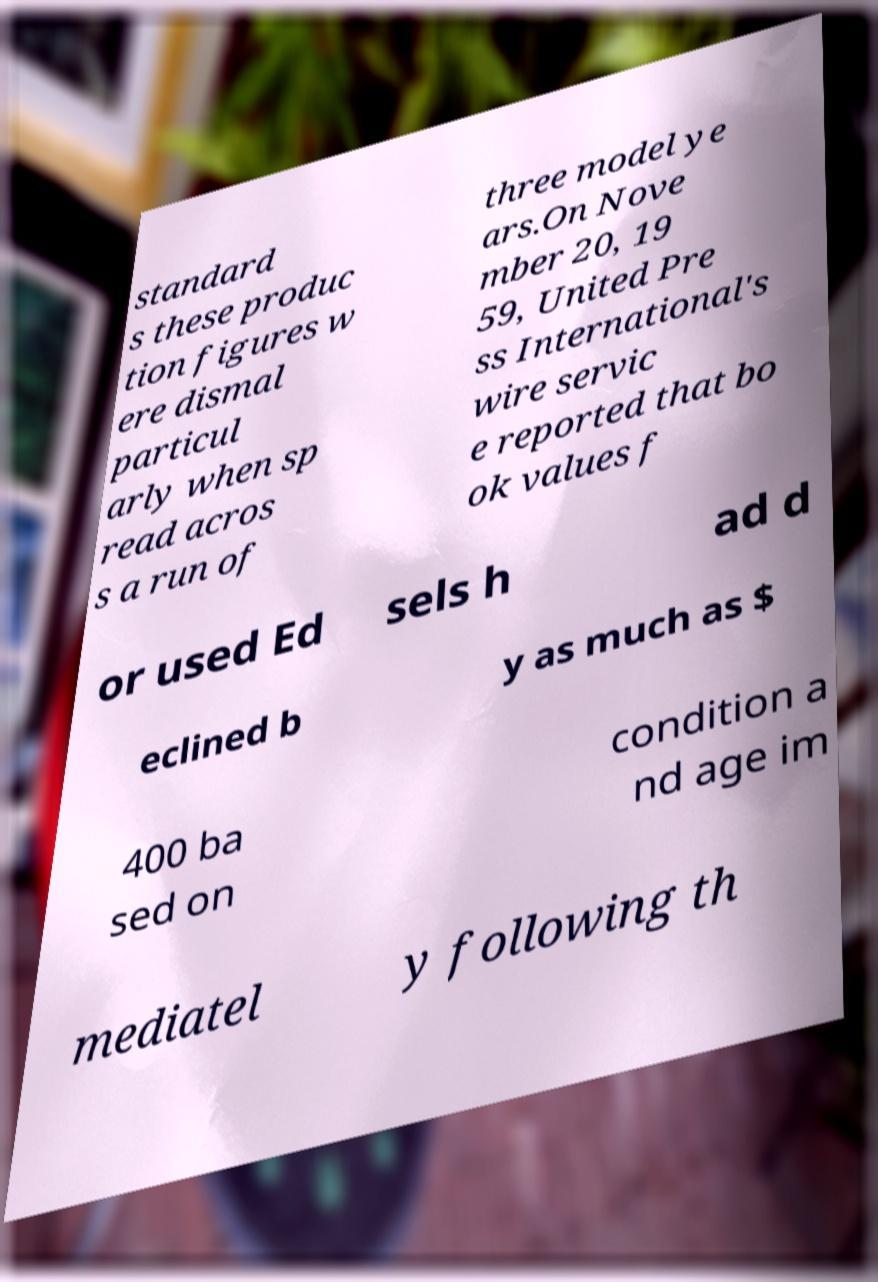For documentation purposes, I need the text within this image transcribed. Could you provide that? standard s these produc tion figures w ere dismal particul arly when sp read acros s a run of three model ye ars.On Nove mber 20, 19 59, United Pre ss International's wire servic e reported that bo ok values f or used Ed sels h ad d eclined b y as much as $ 400 ba sed on condition a nd age im mediatel y following th 